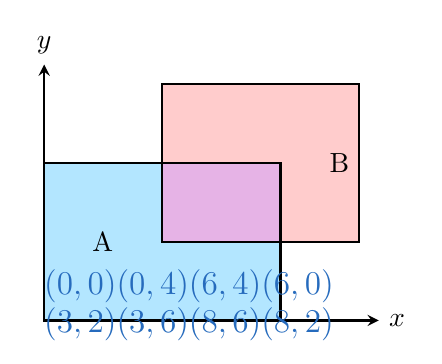Teach me how to tackle this problem. To determine the area of overlap between the two polygons, follow these steps:

1. Identify the overlapping region:
   The overlapping region is also a rectangle, defined by the points:
   $(3,2)$, $(3,4)$, $(6,4)$, $(6,2)$

2. Calculate the width of the overlapping rectangle:
   $width = 6 - 3 = 3$ units

3. Calculate the height of the overlapping rectangle:
   $height = 4 - 2 = 2$ units

4. Apply the formula for the area of a rectangle:
   $$A = width \times height$$
   $$A = 3 \times 2 = 6$$

Therefore, the area of overlap between the two polygons is 6 square units.
Answer: $6$ square units 